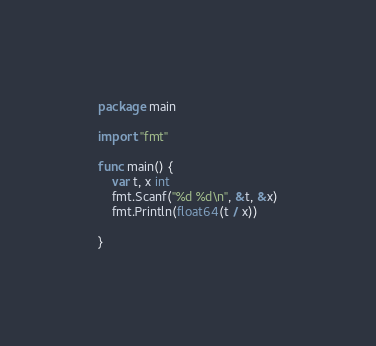<code> <loc_0><loc_0><loc_500><loc_500><_Go_>package main

import "fmt"

func main() {
	var t, x int
	fmt.Scanf("%d %d\n", &t, &x)
	fmt.Println(float64(t / x))

}</code> 